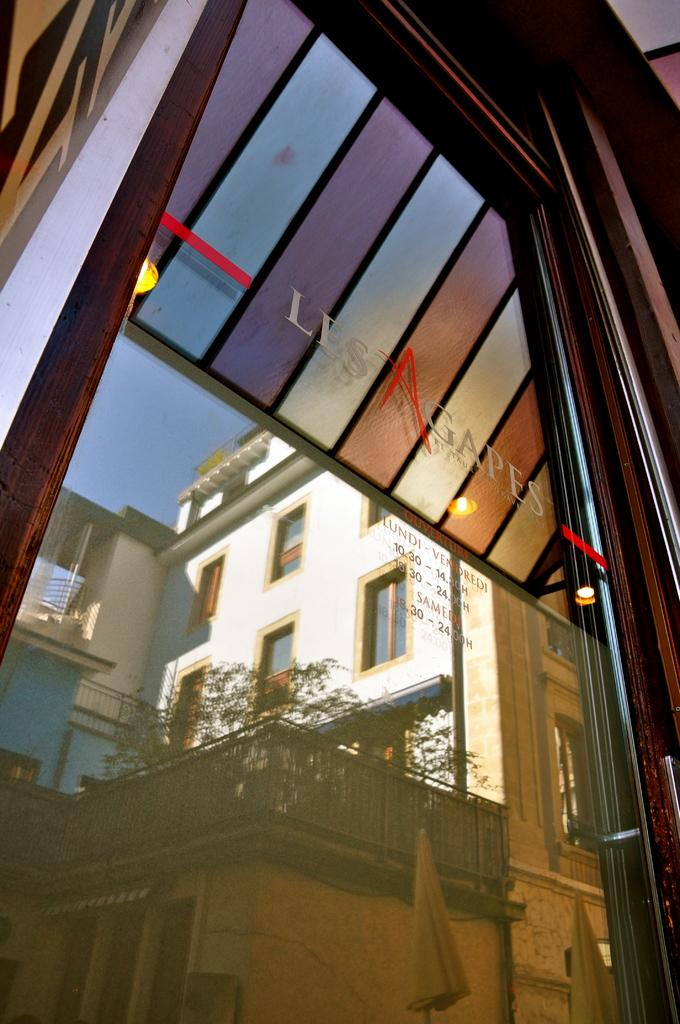What is the main feature of the door in the image? The door has glass in the image. Is there any writing or symbols on the door? Yes, there is text on the door. What type of structure is visible in the image? There is a building in the image. What can be seen growing in the image? There are plants in the image. What is used to enclose or separate areas in the image? There is a fence in the image. What can be seen above the building and fence in the image? The sky is visible in the image. What is visible through the glass on the door? There are objects visible through the glass. Is the spy currently shaking hands with someone in the image? There is no spy or handshake present in the image. 